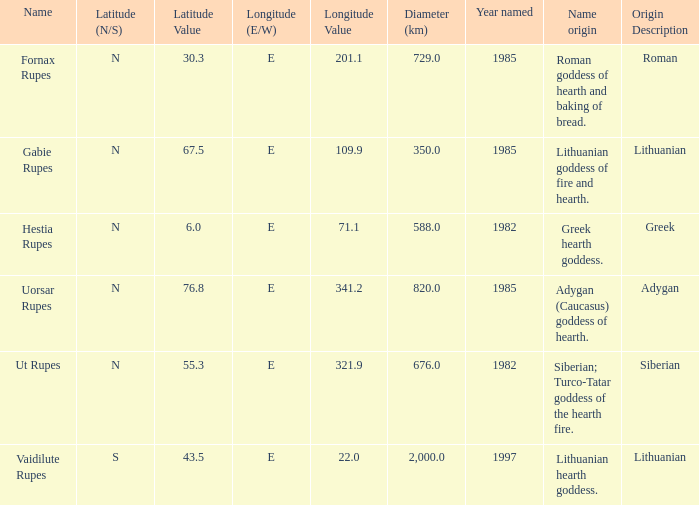What was the diameter of the feature found in 1997? 2000.0. 